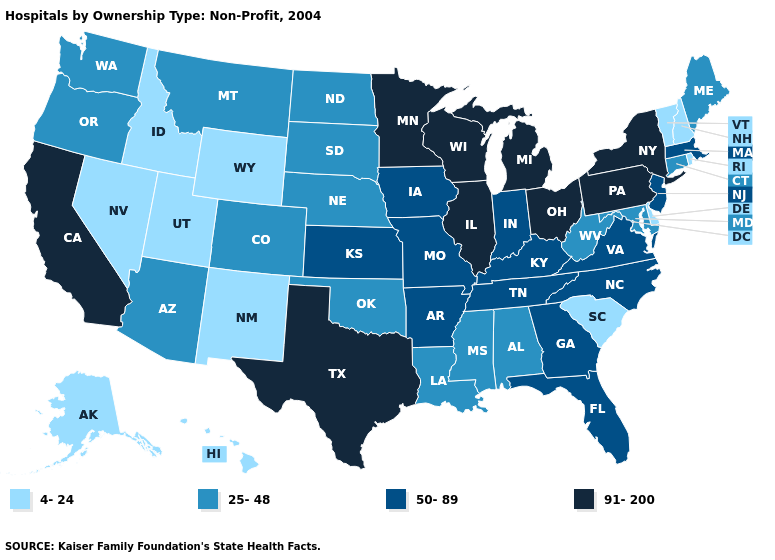Does the first symbol in the legend represent the smallest category?
Give a very brief answer. Yes. Does Oregon have the highest value in the USA?
Quick response, please. No. Name the states that have a value in the range 50-89?
Answer briefly. Arkansas, Florida, Georgia, Indiana, Iowa, Kansas, Kentucky, Massachusetts, Missouri, New Jersey, North Carolina, Tennessee, Virginia. What is the lowest value in the USA?
Be succinct. 4-24. What is the value of Michigan?
Be succinct. 91-200. Does South Carolina have the lowest value in the South?
Be succinct. Yes. Which states hav the highest value in the MidWest?
Be succinct. Illinois, Michigan, Minnesota, Ohio, Wisconsin. Name the states that have a value in the range 91-200?
Concise answer only. California, Illinois, Michigan, Minnesota, New York, Ohio, Pennsylvania, Texas, Wisconsin. Name the states that have a value in the range 4-24?
Answer briefly. Alaska, Delaware, Hawaii, Idaho, Nevada, New Hampshire, New Mexico, Rhode Island, South Carolina, Utah, Vermont, Wyoming. Which states hav the highest value in the South?
Quick response, please. Texas. What is the value of Nebraska?
Short answer required. 25-48. How many symbols are there in the legend?
Keep it brief. 4. Among the states that border Georgia , does Alabama have the highest value?
Write a very short answer. No. Does New Mexico have the lowest value in the West?
Be succinct. Yes. What is the lowest value in the MidWest?
Short answer required. 25-48. 